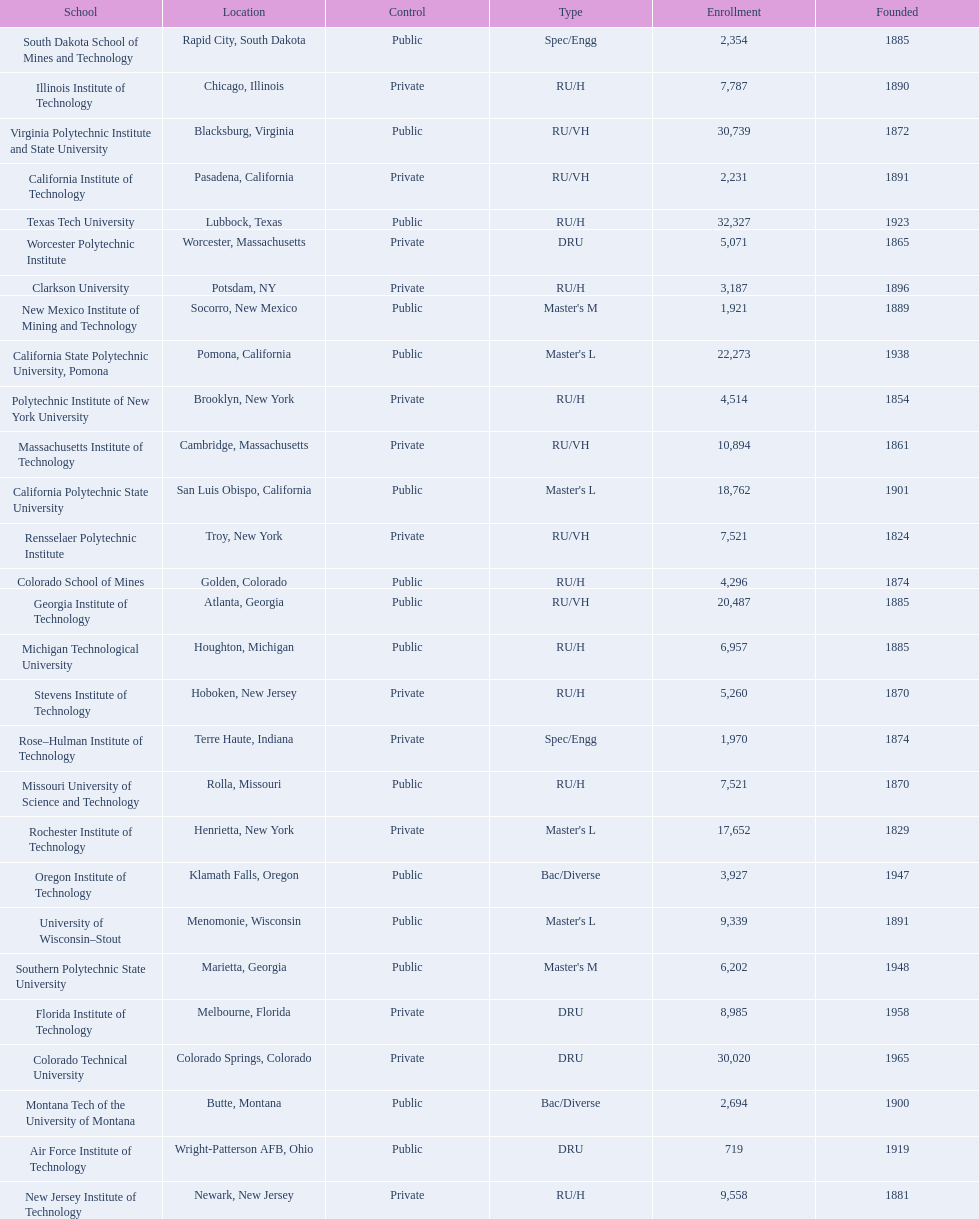Which us technological university has the top enrollment numbers? Texas Tech University. 